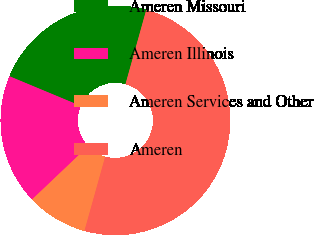<chart> <loc_0><loc_0><loc_500><loc_500><pie_chart><fcel>Ameren Missouri<fcel>Ameren Illinois<fcel>Ameren Services and Other<fcel>Ameren<nl><fcel>23.06%<fcel>18.37%<fcel>8.57%<fcel>50.0%<nl></chart> 